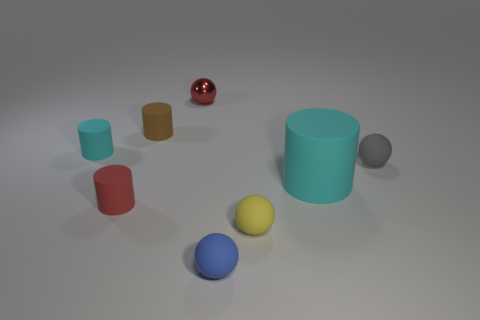Add 2 yellow balls. How many objects exist? 10 Subtract 0 gray cylinders. How many objects are left? 8 Subtract all big brown matte cubes. Subtract all large cyan rubber cylinders. How many objects are left? 7 Add 5 small gray balls. How many small gray balls are left? 6 Add 7 cyan things. How many cyan things exist? 9 